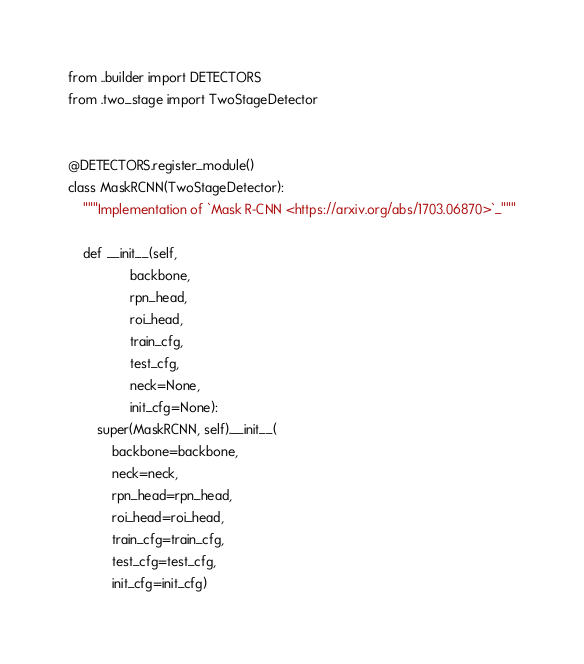Convert code to text. <code><loc_0><loc_0><loc_500><loc_500><_Python_>from ..builder import DETECTORS
from .two_stage import TwoStageDetector


@DETECTORS.register_module()
class MaskRCNN(TwoStageDetector):
    """Implementation of `Mask R-CNN <https://arxiv.org/abs/1703.06870>`_"""

    def __init__(self,
                 backbone,
                 rpn_head,
                 roi_head,
                 train_cfg,
                 test_cfg,
                 neck=None,
                 init_cfg=None):
        super(MaskRCNN, self).__init__(
            backbone=backbone,
            neck=neck,
            rpn_head=rpn_head,
            roi_head=roi_head,
            train_cfg=train_cfg,
            test_cfg=test_cfg,
            init_cfg=init_cfg)
</code> 